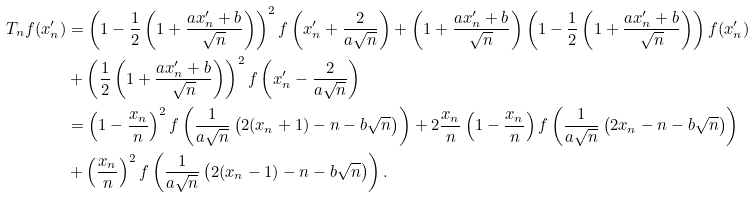<formula> <loc_0><loc_0><loc_500><loc_500>T _ { n } f ( x ^ { \prime } _ { n } ) & = \left ( 1 - \frac { 1 } { 2 } \left ( 1 + \frac { a x ^ { \prime } _ { n } + b } { \sqrt { n } } \right ) \right ) ^ { 2 } f \left ( x _ { n } ^ { \prime } + \frac { 2 } { a \sqrt { n } } \right ) + \left ( 1 + \frac { a x ^ { \prime } _ { n } + b } { \sqrt { n } } \right ) \left ( 1 - \frac { 1 } { 2 } \left ( 1 + \frac { a x ^ { \prime } _ { n } + b } { \sqrt { n } } \right ) \right ) f ( x ^ { \prime } _ { n } ) \\ & + \left ( \frac { 1 } { 2 } \left ( 1 + \frac { a x ^ { \prime } _ { n } + b } { \sqrt { n } } \right ) \right ) ^ { 2 } f \left ( x ^ { \prime } _ { n } - \frac { 2 } { a \sqrt { n } } \right ) \\ & = \left ( 1 - \frac { x _ { n } } { n } \right ) ^ { 2 } f \left ( \frac { 1 } { a \sqrt { n } } \left ( 2 ( x _ { n } + 1 ) - n - b \sqrt { n } \right ) \right ) + 2 \frac { x _ { n } } { n } \left ( 1 - \frac { x _ { n } } { n } \right ) f \left ( \frac { 1 } { a \sqrt { n } } \left ( 2 x _ { n } - n - b \sqrt { n } \right ) \right ) \\ & + \left ( \frac { x _ { n } } { n } \right ) ^ { 2 } f \left ( \frac { 1 } { a \sqrt { n } } \left ( 2 ( x _ { n } - 1 ) - n - b \sqrt { n } \right ) \right ) .</formula> 